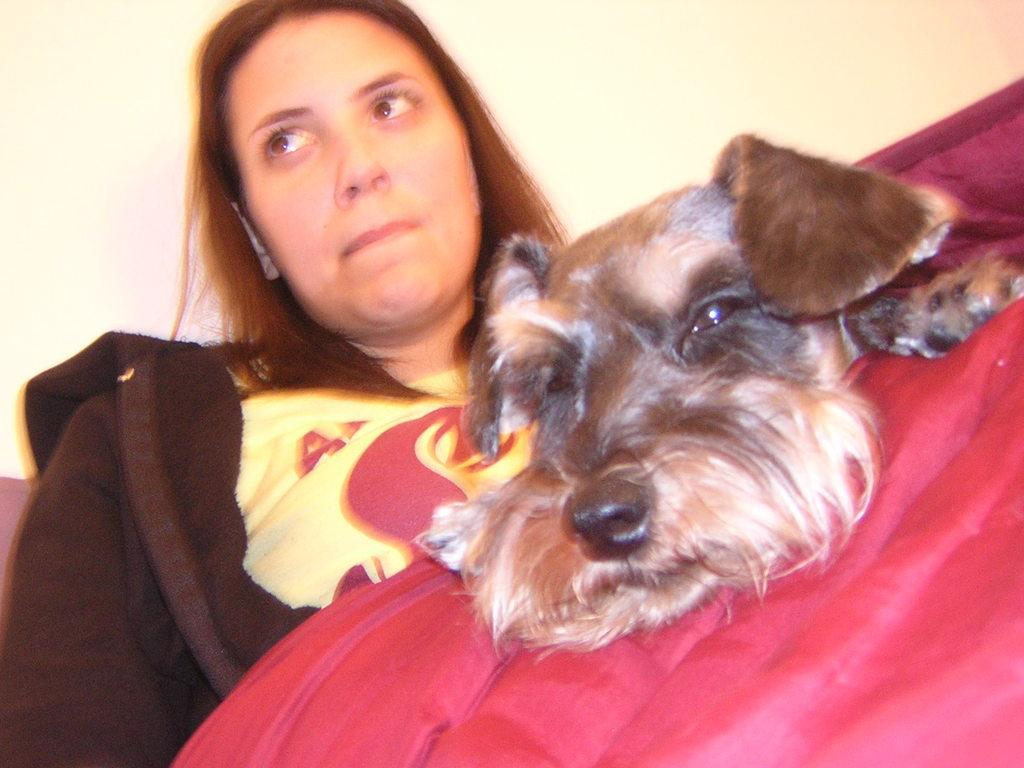Who is present in the image? There is a woman in the image. What color or object can be seen related to the woman? There is a red object or clothing in the image. What other living creature is in the image? There is a dog in the image. What can be seen behind the woman and the dog? There is a plain wall in the background of the image. Can you hear the sheep coughing in the image? There are no sheep or any indication of coughing in the image. 